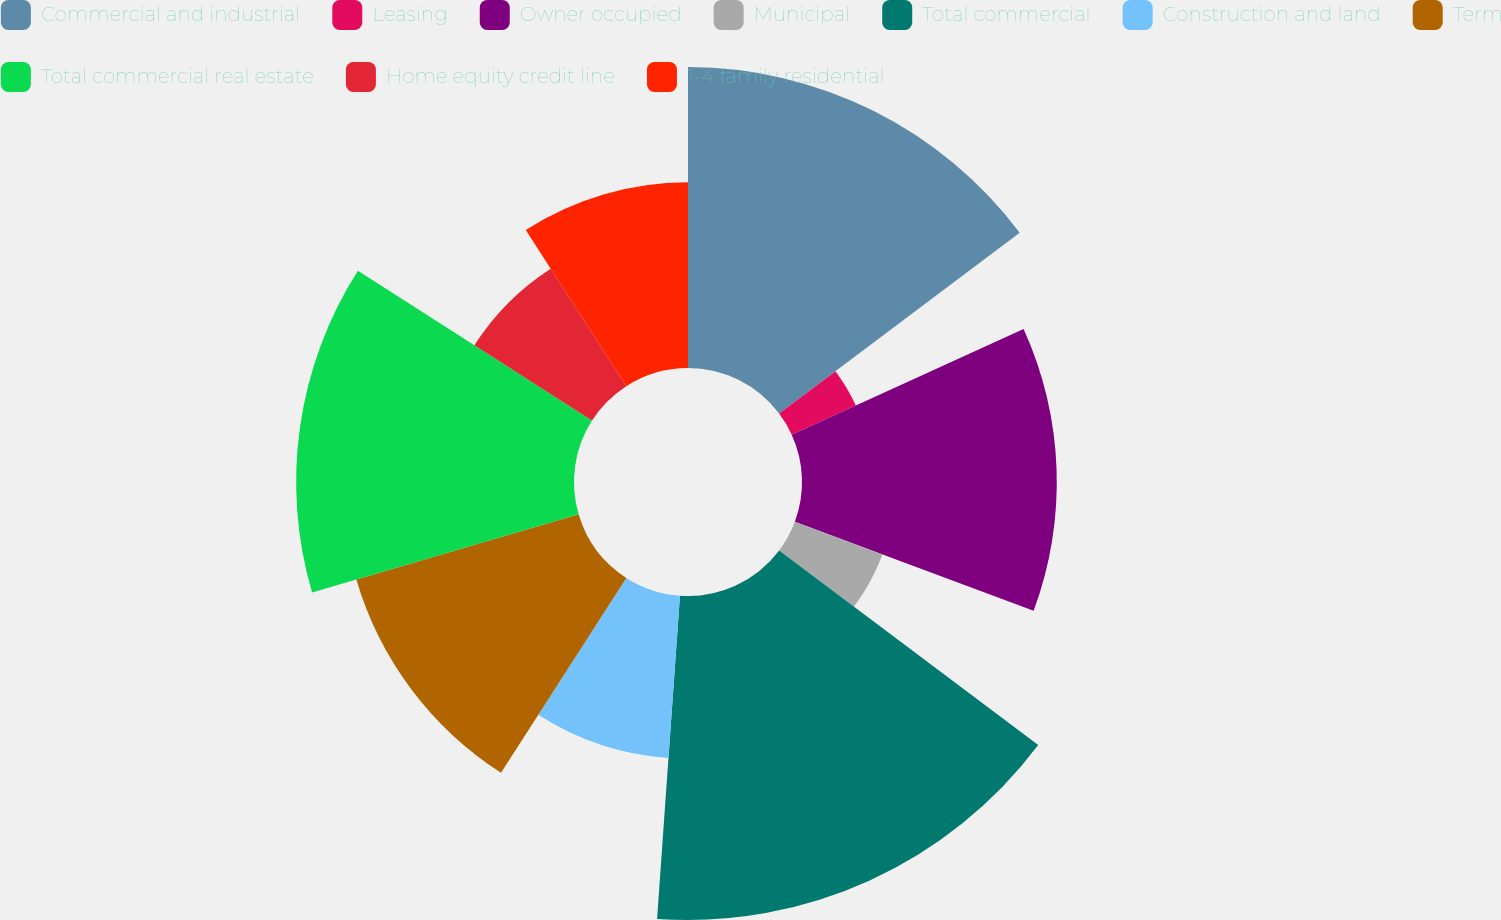Convert chart. <chart><loc_0><loc_0><loc_500><loc_500><pie_chart><fcel>Commercial and industrial<fcel>Leasing<fcel>Owner occupied<fcel>Municipal<fcel>Total commercial<fcel>Construction and land<fcel>Term<fcel>Total commercial real estate<fcel>Home equity credit line<fcel>1-4 family residential<nl><fcel>14.74%<fcel>3.45%<fcel>12.48%<fcel>4.58%<fcel>15.87%<fcel>7.97%<fcel>11.35%<fcel>13.61%<fcel>6.84%<fcel>9.1%<nl></chart> 